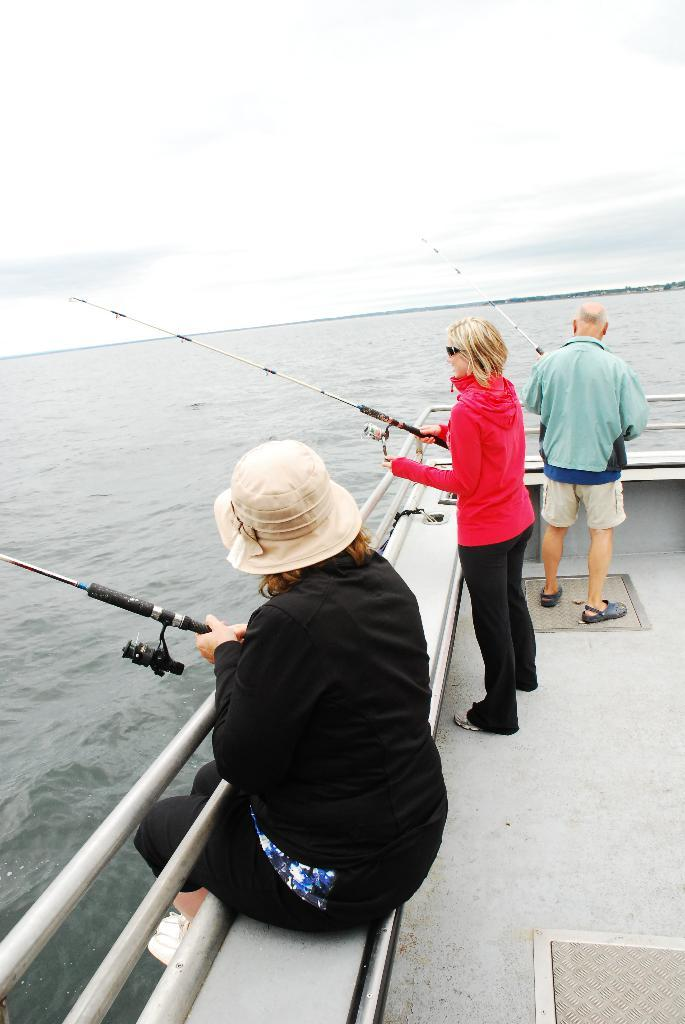How many people are in the image? There are three persons in the image. What are the persons doing in the image? The persons are holding fishing rods. What is the position of one of the persons in the image? One person is sitting. What natural elements can be seen in the image? There is water and sky visible in the image. What team are the persons supporting in the image? There is no indication of a team or any sports-related activity in the image. 